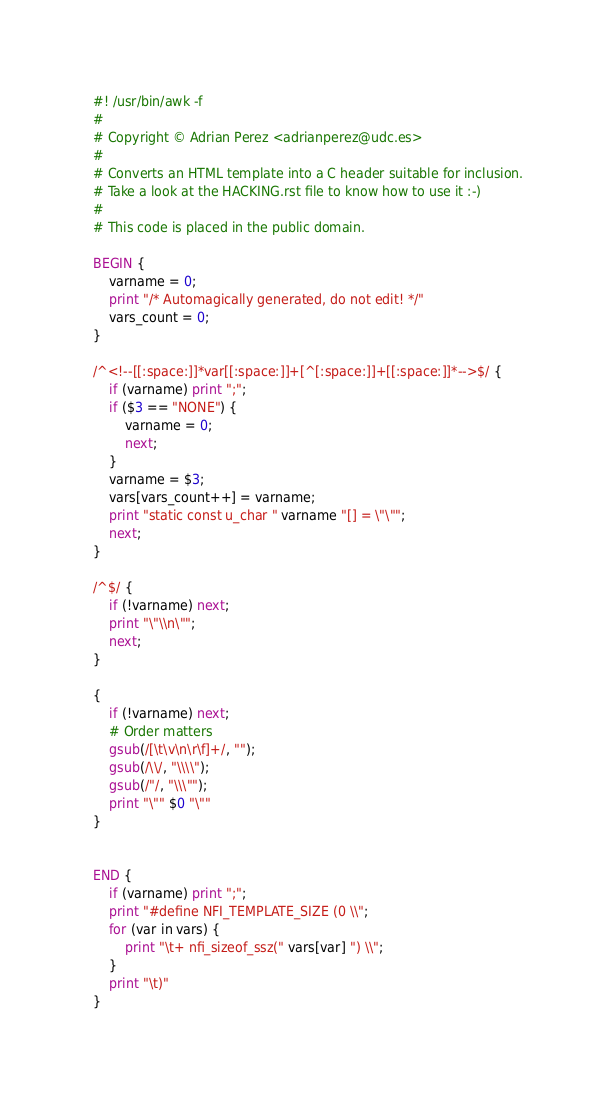<code> <loc_0><loc_0><loc_500><loc_500><_Awk_>#! /usr/bin/awk -f
#
# Copyright © Adrian Perez <adrianperez@udc.es>
#
# Converts an HTML template into a C header suitable for inclusion.
# Take a look at the HACKING.rst file to know how to use it :-)
#
# This code is placed in the public domain.

BEGIN {
	varname = 0;
	print "/* Automagically generated, do not edit! */"
	vars_count = 0;
}

/^<!--[[:space:]]*var[[:space:]]+[^[:space:]]+[[:space:]]*-->$/ {
	if (varname) print ";";
	if ($3 == "NONE") {
		varname = 0;
		next;
	}
	varname = $3;
	vars[vars_count++] = varname;
	print "static const u_char " varname "[] = \"\"";
	next;
}

/^$/ {
	if (!varname) next;
	print "\"\\n\"";
	next;
}

{
	if (!varname) next;
	# Order matters
	gsub(/[\t\v\n\r\f]+/, "");
	gsub(/\\/, "\\\\");
	gsub(/"/, "\\\"");
	print "\"" $0 "\""
}


END {
	if (varname) print ";";
	print "#define NFI_TEMPLATE_SIZE (0 \\";
	for (var in vars) {
		print "\t+ nfi_sizeof_ssz(" vars[var] ") \\";
	}
	print "\t)"
}

</code> 